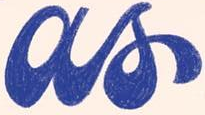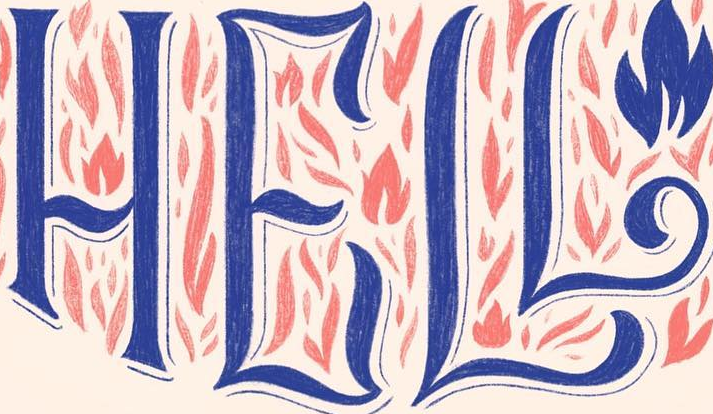Read the text from these images in sequence, separated by a semicolon. as; HELL 